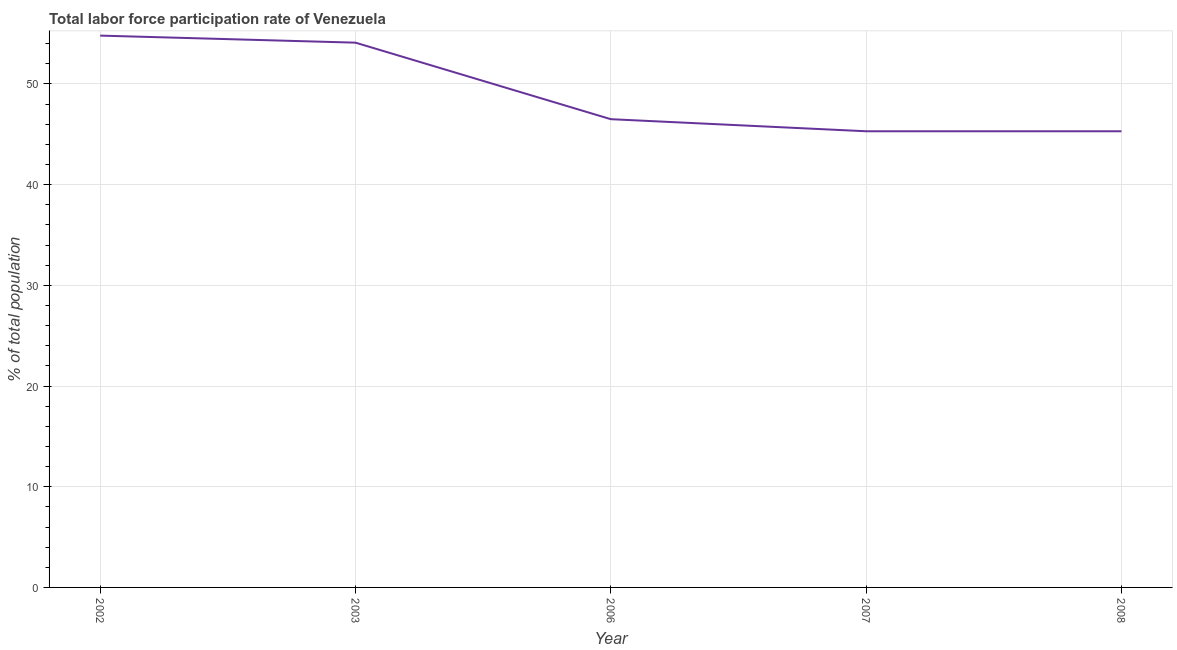What is the total labor force participation rate in 2008?
Keep it short and to the point. 45.3. Across all years, what is the maximum total labor force participation rate?
Your response must be concise. 54.8. Across all years, what is the minimum total labor force participation rate?
Your answer should be compact. 45.3. In which year was the total labor force participation rate maximum?
Offer a terse response. 2002. In which year was the total labor force participation rate minimum?
Your answer should be very brief. 2007. What is the sum of the total labor force participation rate?
Make the answer very short. 246. What is the difference between the total labor force participation rate in 2006 and 2008?
Your answer should be very brief. 1.2. What is the average total labor force participation rate per year?
Give a very brief answer. 49.2. What is the median total labor force participation rate?
Provide a succinct answer. 46.5. What is the ratio of the total labor force participation rate in 2002 to that in 2003?
Your response must be concise. 1.01. What is the difference between the highest and the second highest total labor force participation rate?
Your answer should be compact. 0.7. Does the total labor force participation rate monotonically increase over the years?
Your response must be concise. No. How many years are there in the graph?
Make the answer very short. 5. Are the values on the major ticks of Y-axis written in scientific E-notation?
Your response must be concise. No. Does the graph contain any zero values?
Offer a terse response. No. Does the graph contain grids?
Your response must be concise. Yes. What is the title of the graph?
Give a very brief answer. Total labor force participation rate of Venezuela. What is the label or title of the X-axis?
Your response must be concise. Year. What is the label or title of the Y-axis?
Keep it short and to the point. % of total population. What is the % of total population in 2002?
Your answer should be very brief. 54.8. What is the % of total population in 2003?
Offer a terse response. 54.1. What is the % of total population in 2006?
Your response must be concise. 46.5. What is the % of total population of 2007?
Keep it short and to the point. 45.3. What is the % of total population of 2008?
Provide a succinct answer. 45.3. What is the difference between the % of total population in 2002 and 2006?
Your answer should be compact. 8.3. What is the difference between the % of total population in 2002 and 2008?
Provide a succinct answer. 9.5. What is the difference between the % of total population in 2003 and 2006?
Your response must be concise. 7.6. What is the difference between the % of total population in 2003 and 2007?
Offer a very short reply. 8.8. What is the ratio of the % of total population in 2002 to that in 2003?
Your response must be concise. 1.01. What is the ratio of the % of total population in 2002 to that in 2006?
Offer a very short reply. 1.18. What is the ratio of the % of total population in 2002 to that in 2007?
Your response must be concise. 1.21. What is the ratio of the % of total population in 2002 to that in 2008?
Your answer should be compact. 1.21. What is the ratio of the % of total population in 2003 to that in 2006?
Your response must be concise. 1.16. What is the ratio of the % of total population in 2003 to that in 2007?
Provide a succinct answer. 1.19. What is the ratio of the % of total population in 2003 to that in 2008?
Ensure brevity in your answer.  1.19. What is the ratio of the % of total population in 2006 to that in 2008?
Provide a succinct answer. 1.03. 